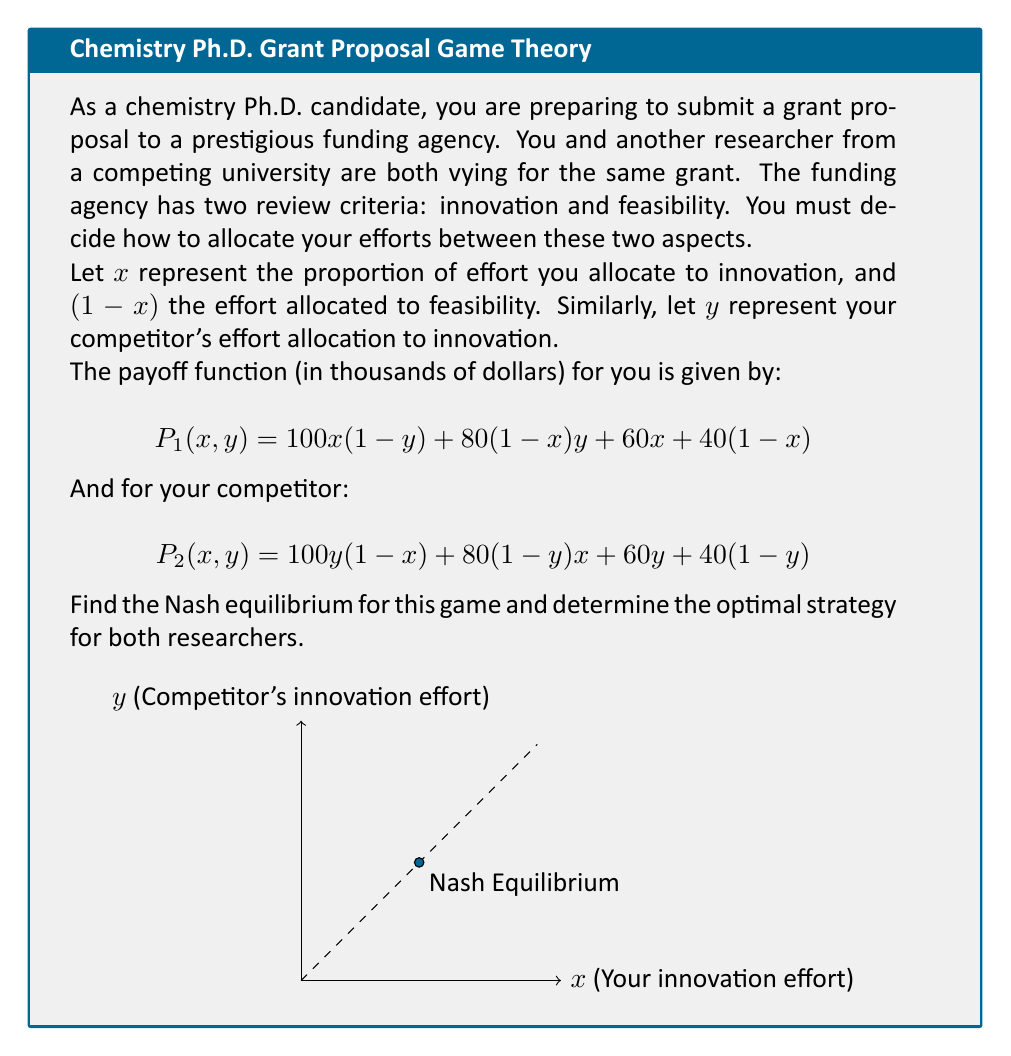Help me with this question. To find the Nash equilibrium, we need to determine the best response functions for both players and find their intersection.

Step 1: Find your best response function
Differentiate $P_1(x,y)$ with respect to $x$ and set it to zero:

$$\frac{\partial P_1}{\partial x} = 100(1-y) + 60 - 80y - 40 = 0$$
$$60 - 180y = 0$$
$$y = \frac{1}{3}$$

This means your best response is to choose $x = 1$ when $y < \frac{1}{3}$, and $x = 0$ when $y > \frac{1}{3}$.

Step 2: Find your competitor's best response function
Similarly, differentiate $P_2(x,y)$ with respect to $y$ and set it to zero:

$$\frac{\partial P_2}{\partial y} = 100(1-x) + 60 - 80x - 40 = 0$$
$$60 - 180x = 0$$
$$x = \frac{1}{3}$$

Your competitor's best response is to choose $y = 1$ when $x < \frac{1}{3}$, and $y = 0$ when $x > \frac{1}{3}$.

Step 3: Find the Nash equilibrium
The Nash equilibrium occurs where the best response functions intersect. This happens when $x = y = \frac{1}{3}$.

Step 4: Verify the equilibrium
At $(x, y) = (\frac{1}{3}, \frac{1}{3})$, neither player can unilaterally improve their payoff by changing their strategy.

Step 5: Calculate the payoffs at equilibrium
For you: $P_1(\frac{1}{3}, \frac{1}{3}) = 100 \cdot \frac{1}{3} \cdot \frac{2}{3} + 80 \cdot \frac{2}{3} \cdot \frac{1}{3} + 60 \cdot \frac{1}{3} + 40 \cdot \frac{2}{3} = 60$

For your competitor: $P_2(\frac{1}{3}, \frac{1}{3}) = 60$ (by symmetry)

Therefore, the Nash equilibrium strategy for both researchers is to allocate $\frac{1}{3}$ of their efforts to innovation and $\frac{2}{3}$ to feasibility, resulting in an expected grant amount of $60,000 for each.
Answer: Nash equilibrium: $(x, y) = (\frac{1}{3}, \frac{1}{3})$. Optimal strategy: Allocate $\frac{1}{3}$ effort to innovation, $\frac{2}{3}$ to feasibility. 